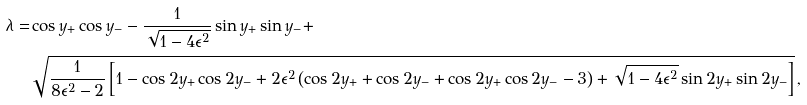Convert formula to latex. <formula><loc_0><loc_0><loc_500><loc_500>\lambda = & \cos { y _ { + } } \cos { y _ { - } } - \frac { 1 } { \sqrt { 1 - 4 \epsilon ^ { 2 } } } \sin { y _ { + } } \sin { y _ { - } } + \\ & \sqrt { \frac { 1 } { 8 \epsilon ^ { 2 } - 2 } \left [ 1 - \cos { 2 y _ { + } } \cos { 2 y _ { - } } + 2 \epsilon ^ { 2 } \left ( \cos { 2 y _ { + } } + \cos { 2 y _ { - } } + \cos { 2 y _ { + } } \cos { 2 y _ { - } } - 3 \right ) + \sqrt { 1 - 4 \epsilon ^ { 2 } } \sin { 2 y _ { + } } \sin { 2 y _ { - } } \right ] } \, ,</formula> 